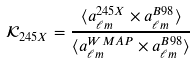<formula> <loc_0><loc_0><loc_500><loc_500>\mathcal { K } _ { 2 4 5 X } = \frac { \langle a _ { \ell m } ^ { 2 4 5 X } \times a _ { \ell m } ^ { B 9 8 } \rangle } { \langle a _ { \ell m } ^ { W M A P } \times a _ { \ell m } ^ { B 9 8 } \rangle }</formula> 